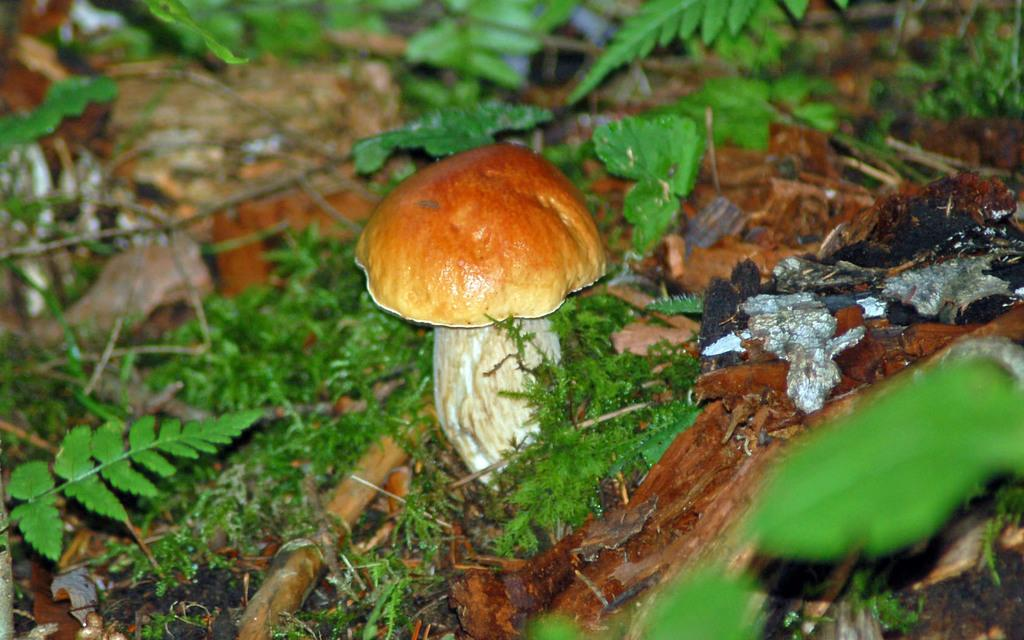What type of surface is visible in the image? There is a surface with grass in the image. What can be seen growing on the surface? There are plant saplings and a mushroom on the surface. Can you describe any other visible elements near the surface? There is some dust visible near the surface. What type of legal advice is the farmer seeking in the image? There is no farmer or lawyer present in the image, and therefore no legal advice is being sought. 